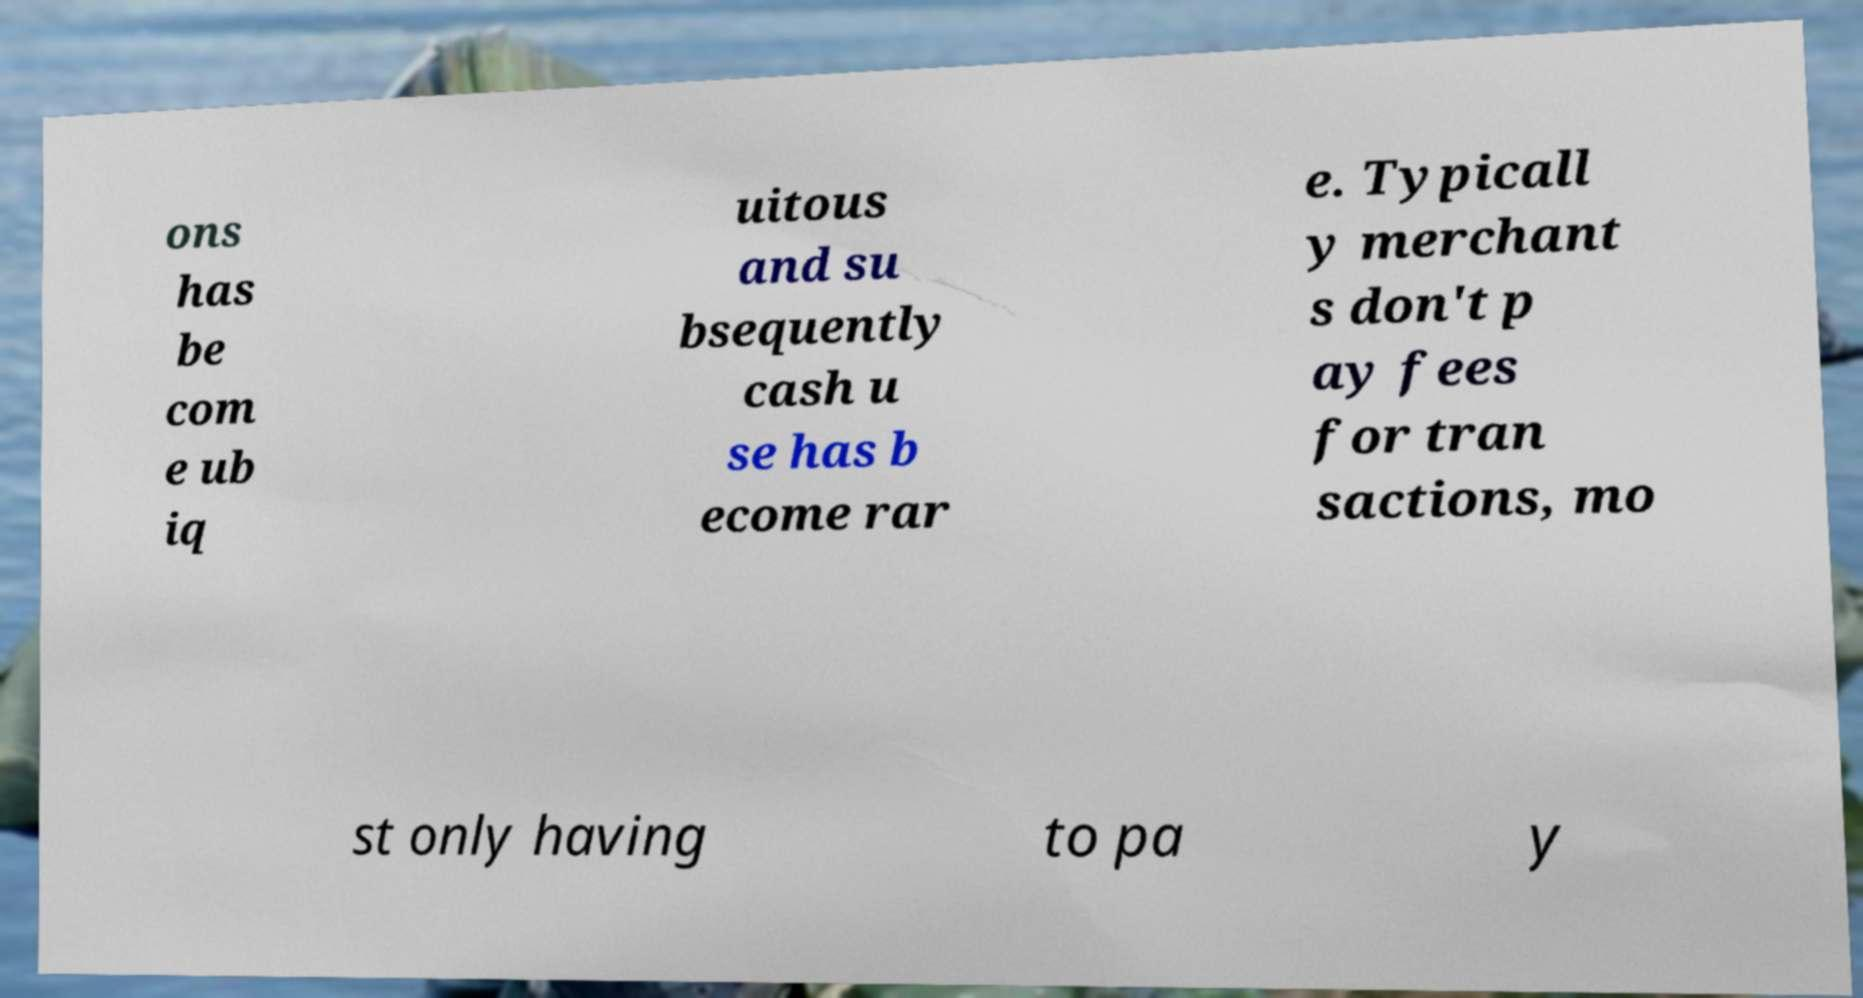What messages or text are displayed in this image? I need them in a readable, typed format. ons has be com e ub iq uitous and su bsequently cash u se has b ecome rar e. Typicall y merchant s don't p ay fees for tran sactions, mo st only having to pa y 